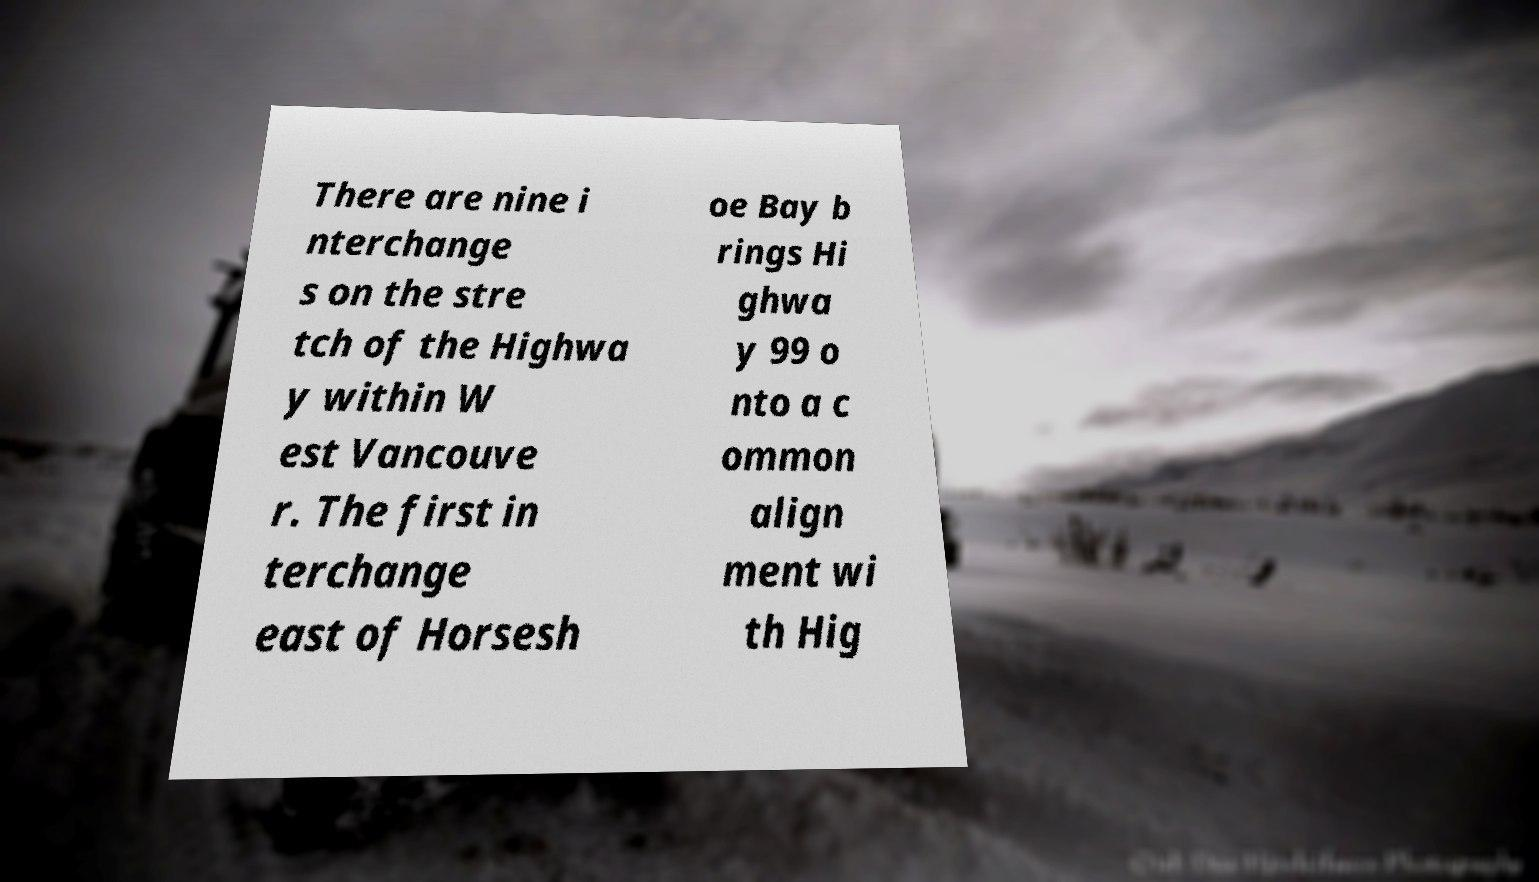What messages or text are displayed in this image? I need them in a readable, typed format. There are nine i nterchange s on the stre tch of the Highwa y within W est Vancouve r. The first in terchange east of Horsesh oe Bay b rings Hi ghwa y 99 o nto a c ommon align ment wi th Hig 